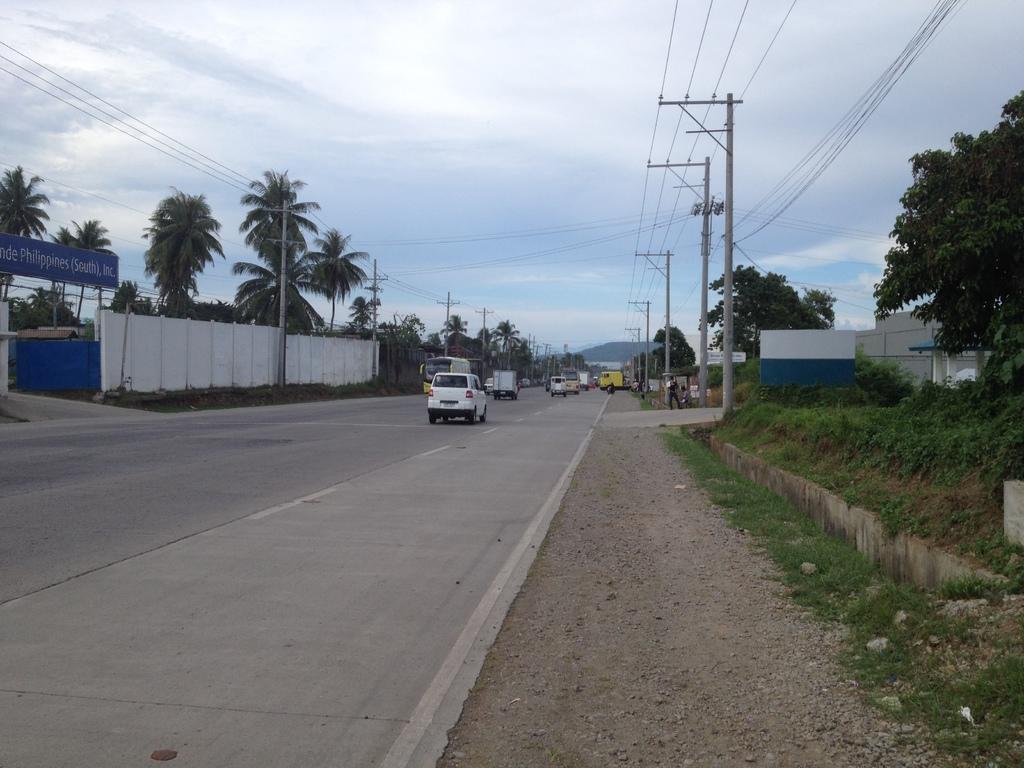Please provide a concise description of this image. In this image we can see the vehicles. On the right side, we can see the poles with wires, trees, plants, grass, person and buildings. On the left side, we can see the wall, game, board with text, poles with wires and the trees. In the background, we can see a mountain. At the top we can see the sky. 